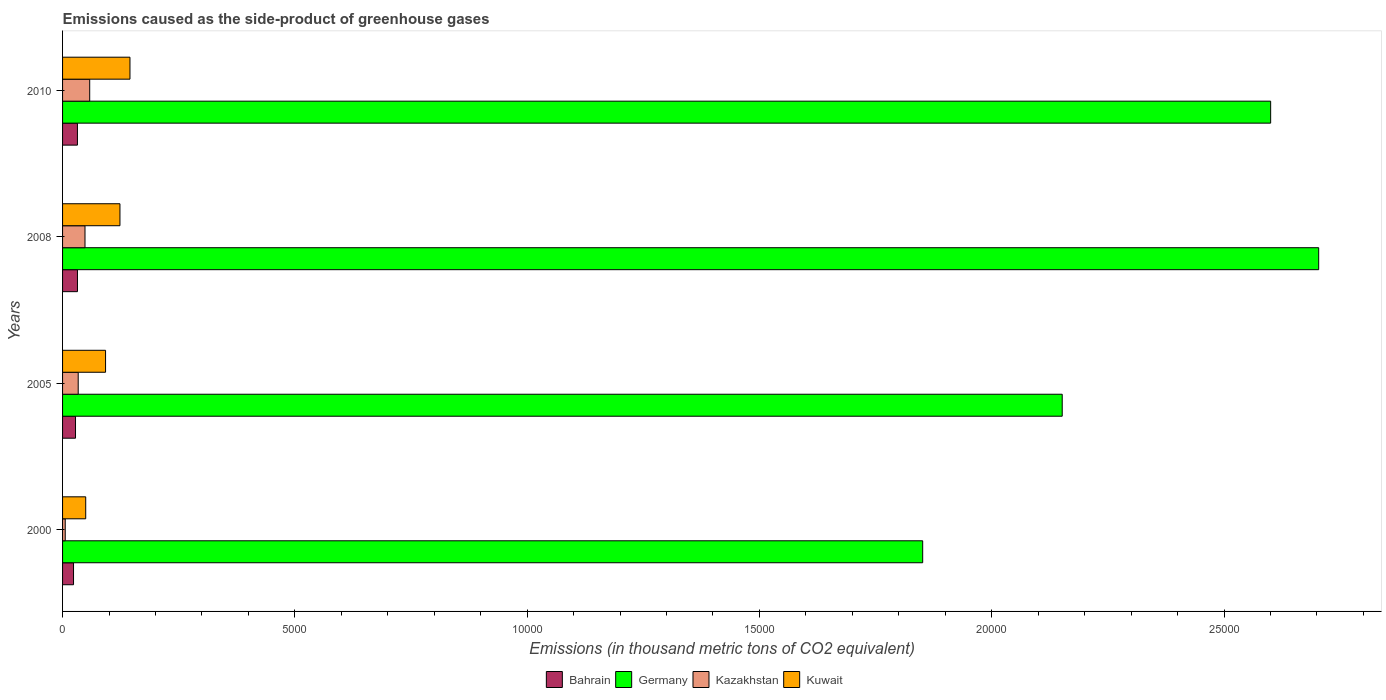How many different coloured bars are there?
Give a very brief answer. 4. Are the number of bars on each tick of the Y-axis equal?
Provide a short and direct response. Yes. How many bars are there on the 4th tick from the bottom?
Provide a short and direct response. 4. What is the label of the 3rd group of bars from the top?
Your response must be concise. 2005. In how many cases, is the number of bars for a given year not equal to the number of legend labels?
Make the answer very short. 0. What is the emissions caused as the side-product of greenhouse gases in Germany in 2008?
Your response must be concise. 2.70e+04. Across all years, what is the maximum emissions caused as the side-product of greenhouse gases in Bahrain?
Offer a terse response. 320.9. Across all years, what is the minimum emissions caused as the side-product of greenhouse gases in Bahrain?
Your response must be concise. 236.1. What is the total emissions caused as the side-product of greenhouse gases in Germany in the graph?
Provide a short and direct response. 9.31e+04. What is the difference between the emissions caused as the side-product of greenhouse gases in Bahrain in 2000 and that in 2005?
Keep it short and to the point. -42.5. What is the difference between the emissions caused as the side-product of greenhouse gases in Germany in 2010 and the emissions caused as the side-product of greenhouse gases in Kazakhstan in 2000?
Offer a terse response. 2.59e+04. What is the average emissions caused as the side-product of greenhouse gases in Kuwait per year?
Offer a terse response. 1027.55. In the year 2008, what is the difference between the emissions caused as the side-product of greenhouse gases in Kuwait and emissions caused as the side-product of greenhouse gases in Germany?
Your response must be concise. -2.58e+04. What is the ratio of the emissions caused as the side-product of greenhouse gases in Kazakhstan in 2005 to that in 2008?
Ensure brevity in your answer.  0.7. What is the difference between the highest and the second highest emissions caused as the side-product of greenhouse gases in Kazakhstan?
Your response must be concise. 101.1. What is the difference between the highest and the lowest emissions caused as the side-product of greenhouse gases in Kazakhstan?
Your answer should be very brief. 526.5. Is the sum of the emissions caused as the side-product of greenhouse gases in Kuwait in 2000 and 2005 greater than the maximum emissions caused as the side-product of greenhouse gases in Bahrain across all years?
Ensure brevity in your answer.  Yes. What does the 3rd bar from the top in 2008 represents?
Keep it short and to the point. Germany. What does the 3rd bar from the bottom in 2000 represents?
Provide a short and direct response. Kazakhstan. How many bars are there?
Give a very brief answer. 16. How many years are there in the graph?
Make the answer very short. 4. Are the values on the major ticks of X-axis written in scientific E-notation?
Offer a terse response. No. Where does the legend appear in the graph?
Your answer should be very brief. Bottom center. How are the legend labels stacked?
Make the answer very short. Horizontal. What is the title of the graph?
Provide a succinct answer. Emissions caused as the side-product of greenhouse gases. What is the label or title of the X-axis?
Offer a very short reply. Emissions (in thousand metric tons of CO2 equivalent). What is the Emissions (in thousand metric tons of CO2 equivalent) of Bahrain in 2000?
Ensure brevity in your answer.  236.1. What is the Emissions (in thousand metric tons of CO2 equivalent) in Germany in 2000?
Ensure brevity in your answer.  1.85e+04. What is the Emissions (in thousand metric tons of CO2 equivalent) in Kazakhstan in 2000?
Keep it short and to the point. 57.5. What is the Emissions (in thousand metric tons of CO2 equivalent) of Kuwait in 2000?
Your response must be concise. 498.2. What is the Emissions (in thousand metric tons of CO2 equivalent) in Bahrain in 2005?
Offer a very short reply. 278.6. What is the Emissions (in thousand metric tons of CO2 equivalent) in Germany in 2005?
Ensure brevity in your answer.  2.15e+04. What is the Emissions (in thousand metric tons of CO2 equivalent) in Kazakhstan in 2005?
Provide a succinct answer. 336.7. What is the Emissions (in thousand metric tons of CO2 equivalent) of Kuwait in 2005?
Provide a succinct answer. 925.6. What is the Emissions (in thousand metric tons of CO2 equivalent) of Bahrain in 2008?
Provide a succinct answer. 320.9. What is the Emissions (in thousand metric tons of CO2 equivalent) in Germany in 2008?
Your answer should be very brief. 2.70e+04. What is the Emissions (in thousand metric tons of CO2 equivalent) of Kazakhstan in 2008?
Keep it short and to the point. 482.9. What is the Emissions (in thousand metric tons of CO2 equivalent) in Kuwait in 2008?
Offer a terse response. 1235.4. What is the Emissions (in thousand metric tons of CO2 equivalent) in Bahrain in 2010?
Keep it short and to the point. 320. What is the Emissions (in thousand metric tons of CO2 equivalent) in Germany in 2010?
Ensure brevity in your answer.  2.60e+04. What is the Emissions (in thousand metric tons of CO2 equivalent) of Kazakhstan in 2010?
Provide a succinct answer. 584. What is the Emissions (in thousand metric tons of CO2 equivalent) in Kuwait in 2010?
Offer a very short reply. 1451. Across all years, what is the maximum Emissions (in thousand metric tons of CO2 equivalent) of Bahrain?
Your response must be concise. 320.9. Across all years, what is the maximum Emissions (in thousand metric tons of CO2 equivalent) of Germany?
Provide a succinct answer. 2.70e+04. Across all years, what is the maximum Emissions (in thousand metric tons of CO2 equivalent) of Kazakhstan?
Offer a terse response. 584. Across all years, what is the maximum Emissions (in thousand metric tons of CO2 equivalent) of Kuwait?
Make the answer very short. 1451. Across all years, what is the minimum Emissions (in thousand metric tons of CO2 equivalent) of Bahrain?
Give a very brief answer. 236.1. Across all years, what is the minimum Emissions (in thousand metric tons of CO2 equivalent) in Germany?
Provide a short and direct response. 1.85e+04. Across all years, what is the minimum Emissions (in thousand metric tons of CO2 equivalent) of Kazakhstan?
Your answer should be very brief. 57.5. Across all years, what is the minimum Emissions (in thousand metric tons of CO2 equivalent) in Kuwait?
Make the answer very short. 498.2. What is the total Emissions (in thousand metric tons of CO2 equivalent) of Bahrain in the graph?
Make the answer very short. 1155.6. What is the total Emissions (in thousand metric tons of CO2 equivalent) of Germany in the graph?
Give a very brief answer. 9.31e+04. What is the total Emissions (in thousand metric tons of CO2 equivalent) of Kazakhstan in the graph?
Give a very brief answer. 1461.1. What is the total Emissions (in thousand metric tons of CO2 equivalent) in Kuwait in the graph?
Your answer should be compact. 4110.2. What is the difference between the Emissions (in thousand metric tons of CO2 equivalent) of Bahrain in 2000 and that in 2005?
Your answer should be compact. -42.5. What is the difference between the Emissions (in thousand metric tons of CO2 equivalent) of Germany in 2000 and that in 2005?
Ensure brevity in your answer.  -3003.6. What is the difference between the Emissions (in thousand metric tons of CO2 equivalent) in Kazakhstan in 2000 and that in 2005?
Your answer should be very brief. -279.2. What is the difference between the Emissions (in thousand metric tons of CO2 equivalent) of Kuwait in 2000 and that in 2005?
Make the answer very short. -427.4. What is the difference between the Emissions (in thousand metric tons of CO2 equivalent) of Bahrain in 2000 and that in 2008?
Your answer should be compact. -84.8. What is the difference between the Emissions (in thousand metric tons of CO2 equivalent) in Germany in 2000 and that in 2008?
Offer a terse response. -8523.9. What is the difference between the Emissions (in thousand metric tons of CO2 equivalent) in Kazakhstan in 2000 and that in 2008?
Make the answer very short. -425.4. What is the difference between the Emissions (in thousand metric tons of CO2 equivalent) in Kuwait in 2000 and that in 2008?
Your answer should be compact. -737.2. What is the difference between the Emissions (in thousand metric tons of CO2 equivalent) of Bahrain in 2000 and that in 2010?
Your answer should be compact. -83.9. What is the difference between the Emissions (in thousand metric tons of CO2 equivalent) of Germany in 2000 and that in 2010?
Offer a very short reply. -7490.1. What is the difference between the Emissions (in thousand metric tons of CO2 equivalent) of Kazakhstan in 2000 and that in 2010?
Your response must be concise. -526.5. What is the difference between the Emissions (in thousand metric tons of CO2 equivalent) of Kuwait in 2000 and that in 2010?
Your response must be concise. -952.8. What is the difference between the Emissions (in thousand metric tons of CO2 equivalent) of Bahrain in 2005 and that in 2008?
Keep it short and to the point. -42.3. What is the difference between the Emissions (in thousand metric tons of CO2 equivalent) in Germany in 2005 and that in 2008?
Your response must be concise. -5520.3. What is the difference between the Emissions (in thousand metric tons of CO2 equivalent) of Kazakhstan in 2005 and that in 2008?
Your answer should be very brief. -146.2. What is the difference between the Emissions (in thousand metric tons of CO2 equivalent) of Kuwait in 2005 and that in 2008?
Give a very brief answer. -309.8. What is the difference between the Emissions (in thousand metric tons of CO2 equivalent) of Bahrain in 2005 and that in 2010?
Give a very brief answer. -41.4. What is the difference between the Emissions (in thousand metric tons of CO2 equivalent) of Germany in 2005 and that in 2010?
Your response must be concise. -4486.5. What is the difference between the Emissions (in thousand metric tons of CO2 equivalent) in Kazakhstan in 2005 and that in 2010?
Your response must be concise. -247.3. What is the difference between the Emissions (in thousand metric tons of CO2 equivalent) of Kuwait in 2005 and that in 2010?
Provide a short and direct response. -525.4. What is the difference between the Emissions (in thousand metric tons of CO2 equivalent) of Germany in 2008 and that in 2010?
Ensure brevity in your answer.  1033.8. What is the difference between the Emissions (in thousand metric tons of CO2 equivalent) in Kazakhstan in 2008 and that in 2010?
Ensure brevity in your answer.  -101.1. What is the difference between the Emissions (in thousand metric tons of CO2 equivalent) in Kuwait in 2008 and that in 2010?
Your response must be concise. -215.6. What is the difference between the Emissions (in thousand metric tons of CO2 equivalent) of Bahrain in 2000 and the Emissions (in thousand metric tons of CO2 equivalent) of Germany in 2005?
Offer a very short reply. -2.13e+04. What is the difference between the Emissions (in thousand metric tons of CO2 equivalent) of Bahrain in 2000 and the Emissions (in thousand metric tons of CO2 equivalent) of Kazakhstan in 2005?
Make the answer very short. -100.6. What is the difference between the Emissions (in thousand metric tons of CO2 equivalent) in Bahrain in 2000 and the Emissions (in thousand metric tons of CO2 equivalent) in Kuwait in 2005?
Your response must be concise. -689.5. What is the difference between the Emissions (in thousand metric tons of CO2 equivalent) in Germany in 2000 and the Emissions (in thousand metric tons of CO2 equivalent) in Kazakhstan in 2005?
Offer a very short reply. 1.82e+04. What is the difference between the Emissions (in thousand metric tons of CO2 equivalent) in Germany in 2000 and the Emissions (in thousand metric tons of CO2 equivalent) in Kuwait in 2005?
Your response must be concise. 1.76e+04. What is the difference between the Emissions (in thousand metric tons of CO2 equivalent) in Kazakhstan in 2000 and the Emissions (in thousand metric tons of CO2 equivalent) in Kuwait in 2005?
Your response must be concise. -868.1. What is the difference between the Emissions (in thousand metric tons of CO2 equivalent) in Bahrain in 2000 and the Emissions (in thousand metric tons of CO2 equivalent) in Germany in 2008?
Provide a short and direct response. -2.68e+04. What is the difference between the Emissions (in thousand metric tons of CO2 equivalent) in Bahrain in 2000 and the Emissions (in thousand metric tons of CO2 equivalent) in Kazakhstan in 2008?
Your response must be concise. -246.8. What is the difference between the Emissions (in thousand metric tons of CO2 equivalent) of Bahrain in 2000 and the Emissions (in thousand metric tons of CO2 equivalent) of Kuwait in 2008?
Give a very brief answer. -999.3. What is the difference between the Emissions (in thousand metric tons of CO2 equivalent) of Germany in 2000 and the Emissions (in thousand metric tons of CO2 equivalent) of Kazakhstan in 2008?
Ensure brevity in your answer.  1.80e+04. What is the difference between the Emissions (in thousand metric tons of CO2 equivalent) in Germany in 2000 and the Emissions (in thousand metric tons of CO2 equivalent) in Kuwait in 2008?
Offer a very short reply. 1.73e+04. What is the difference between the Emissions (in thousand metric tons of CO2 equivalent) of Kazakhstan in 2000 and the Emissions (in thousand metric tons of CO2 equivalent) of Kuwait in 2008?
Give a very brief answer. -1177.9. What is the difference between the Emissions (in thousand metric tons of CO2 equivalent) in Bahrain in 2000 and the Emissions (in thousand metric tons of CO2 equivalent) in Germany in 2010?
Your answer should be very brief. -2.58e+04. What is the difference between the Emissions (in thousand metric tons of CO2 equivalent) of Bahrain in 2000 and the Emissions (in thousand metric tons of CO2 equivalent) of Kazakhstan in 2010?
Keep it short and to the point. -347.9. What is the difference between the Emissions (in thousand metric tons of CO2 equivalent) of Bahrain in 2000 and the Emissions (in thousand metric tons of CO2 equivalent) of Kuwait in 2010?
Provide a succinct answer. -1214.9. What is the difference between the Emissions (in thousand metric tons of CO2 equivalent) of Germany in 2000 and the Emissions (in thousand metric tons of CO2 equivalent) of Kazakhstan in 2010?
Keep it short and to the point. 1.79e+04. What is the difference between the Emissions (in thousand metric tons of CO2 equivalent) in Germany in 2000 and the Emissions (in thousand metric tons of CO2 equivalent) in Kuwait in 2010?
Keep it short and to the point. 1.71e+04. What is the difference between the Emissions (in thousand metric tons of CO2 equivalent) of Kazakhstan in 2000 and the Emissions (in thousand metric tons of CO2 equivalent) of Kuwait in 2010?
Give a very brief answer. -1393.5. What is the difference between the Emissions (in thousand metric tons of CO2 equivalent) in Bahrain in 2005 and the Emissions (in thousand metric tons of CO2 equivalent) in Germany in 2008?
Ensure brevity in your answer.  -2.68e+04. What is the difference between the Emissions (in thousand metric tons of CO2 equivalent) of Bahrain in 2005 and the Emissions (in thousand metric tons of CO2 equivalent) of Kazakhstan in 2008?
Offer a very short reply. -204.3. What is the difference between the Emissions (in thousand metric tons of CO2 equivalent) of Bahrain in 2005 and the Emissions (in thousand metric tons of CO2 equivalent) of Kuwait in 2008?
Offer a terse response. -956.8. What is the difference between the Emissions (in thousand metric tons of CO2 equivalent) in Germany in 2005 and the Emissions (in thousand metric tons of CO2 equivalent) in Kazakhstan in 2008?
Keep it short and to the point. 2.10e+04. What is the difference between the Emissions (in thousand metric tons of CO2 equivalent) in Germany in 2005 and the Emissions (in thousand metric tons of CO2 equivalent) in Kuwait in 2008?
Keep it short and to the point. 2.03e+04. What is the difference between the Emissions (in thousand metric tons of CO2 equivalent) of Kazakhstan in 2005 and the Emissions (in thousand metric tons of CO2 equivalent) of Kuwait in 2008?
Ensure brevity in your answer.  -898.7. What is the difference between the Emissions (in thousand metric tons of CO2 equivalent) of Bahrain in 2005 and the Emissions (in thousand metric tons of CO2 equivalent) of Germany in 2010?
Provide a short and direct response. -2.57e+04. What is the difference between the Emissions (in thousand metric tons of CO2 equivalent) in Bahrain in 2005 and the Emissions (in thousand metric tons of CO2 equivalent) in Kazakhstan in 2010?
Provide a short and direct response. -305.4. What is the difference between the Emissions (in thousand metric tons of CO2 equivalent) of Bahrain in 2005 and the Emissions (in thousand metric tons of CO2 equivalent) of Kuwait in 2010?
Ensure brevity in your answer.  -1172.4. What is the difference between the Emissions (in thousand metric tons of CO2 equivalent) of Germany in 2005 and the Emissions (in thousand metric tons of CO2 equivalent) of Kazakhstan in 2010?
Your answer should be compact. 2.09e+04. What is the difference between the Emissions (in thousand metric tons of CO2 equivalent) in Germany in 2005 and the Emissions (in thousand metric tons of CO2 equivalent) in Kuwait in 2010?
Keep it short and to the point. 2.01e+04. What is the difference between the Emissions (in thousand metric tons of CO2 equivalent) of Kazakhstan in 2005 and the Emissions (in thousand metric tons of CO2 equivalent) of Kuwait in 2010?
Your response must be concise. -1114.3. What is the difference between the Emissions (in thousand metric tons of CO2 equivalent) in Bahrain in 2008 and the Emissions (in thousand metric tons of CO2 equivalent) in Germany in 2010?
Provide a short and direct response. -2.57e+04. What is the difference between the Emissions (in thousand metric tons of CO2 equivalent) of Bahrain in 2008 and the Emissions (in thousand metric tons of CO2 equivalent) of Kazakhstan in 2010?
Your response must be concise. -263.1. What is the difference between the Emissions (in thousand metric tons of CO2 equivalent) in Bahrain in 2008 and the Emissions (in thousand metric tons of CO2 equivalent) in Kuwait in 2010?
Offer a very short reply. -1130.1. What is the difference between the Emissions (in thousand metric tons of CO2 equivalent) in Germany in 2008 and the Emissions (in thousand metric tons of CO2 equivalent) in Kazakhstan in 2010?
Provide a succinct answer. 2.65e+04. What is the difference between the Emissions (in thousand metric tons of CO2 equivalent) in Germany in 2008 and the Emissions (in thousand metric tons of CO2 equivalent) in Kuwait in 2010?
Make the answer very short. 2.56e+04. What is the difference between the Emissions (in thousand metric tons of CO2 equivalent) of Kazakhstan in 2008 and the Emissions (in thousand metric tons of CO2 equivalent) of Kuwait in 2010?
Offer a very short reply. -968.1. What is the average Emissions (in thousand metric tons of CO2 equivalent) of Bahrain per year?
Ensure brevity in your answer.  288.9. What is the average Emissions (in thousand metric tons of CO2 equivalent) in Germany per year?
Your answer should be compact. 2.33e+04. What is the average Emissions (in thousand metric tons of CO2 equivalent) of Kazakhstan per year?
Ensure brevity in your answer.  365.27. What is the average Emissions (in thousand metric tons of CO2 equivalent) of Kuwait per year?
Your response must be concise. 1027.55. In the year 2000, what is the difference between the Emissions (in thousand metric tons of CO2 equivalent) of Bahrain and Emissions (in thousand metric tons of CO2 equivalent) of Germany?
Your answer should be compact. -1.83e+04. In the year 2000, what is the difference between the Emissions (in thousand metric tons of CO2 equivalent) of Bahrain and Emissions (in thousand metric tons of CO2 equivalent) of Kazakhstan?
Offer a terse response. 178.6. In the year 2000, what is the difference between the Emissions (in thousand metric tons of CO2 equivalent) in Bahrain and Emissions (in thousand metric tons of CO2 equivalent) in Kuwait?
Provide a succinct answer. -262.1. In the year 2000, what is the difference between the Emissions (in thousand metric tons of CO2 equivalent) of Germany and Emissions (in thousand metric tons of CO2 equivalent) of Kazakhstan?
Make the answer very short. 1.85e+04. In the year 2000, what is the difference between the Emissions (in thousand metric tons of CO2 equivalent) of Germany and Emissions (in thousand metric tons of CO2 equivalent) of Kuwait?
Provide a short and direct response. 1.80e+04. In the year 2000, what is the difference between the Emissions (in thousand metric tons of CO2 equivalent) of Kazakhstan and Emissions (in thousand metric tons of CO2 equivalent) of Kuwait?
Provide a short and direct response. -440.7. In the year 2005, what is the difference between the Emissions (in thousand metric tons of CO2 equivalent) of Bahrain and Emissions (in thousand metric tons of CO2 equivalent) of Germany?
Keep it short and to the point. -2.12e+04. In the year 2005, what is the difference between the Emissions (in thousand metric tons of CO2 equivalent) of Bahrain and Emissions (in thousand metric tons of CO2 equivalent) of Kazakhstan?
Ensure brevity in your answer.  -58.1. In the year 2005, what is the difference between the Emissions (in thousand metric tons of CO2 equivalent) in Bahrain and Emissions (in thousand metric tons of CO2 equivalent) in Kuwait?
Your answer should be very brief. -647. In the year 2005, what is the difference between the Emissions (in thousand metric tons of CO2 equivalent) of Germany and Emissions (in thousand metric tons of CO2 equivalent) of Kazakhstan?
Make the answer very short. 2.12e+04. In the year 2005, what is the difference between the Emissions (in thousand metric tons of CO2 equivalent) of Germany and Emissions (in thousand metric tons of CO2 equivalent) of Kuwait?
Offer a terse response. 2.06e+04. In the year 2005, what is the difference between the Emissions (in thousand metric tons of CO2 equivalent) in Kazakhstan and Emissions (in thousand metric tons of CO2 equivalent) in Kuwait?
Give a very brief answer. -588.9. In the year 2008, what is the difference between the Emissions (in thousand metric tons of CO2 equivalent) of Bahrain and Emissions (in thousand metric tons of CO2 equivalent) of Germany?
Offer a very short reply. -2.67e+04. In the year 2008, what is the difference between the Emissions (in thousand metric tons of CO2 equivalent) of Bahrain and Emissions (in thousand metric tons of CO2 equivalent) of Kazakhstan?
Offer a terse response. -162. In the year 2008, what is the difference between the Emissions (in thousand metric tons of CO2 equivalent) in Bahrain and Emissions (in thousand metric tons of CO2 equivalent) in Kuwait?
Ensure brevity in your answer.  -914.5. In the year 2008, what is the difference between the Emissions (in thousand metric tons of CO2 equivalent) of Germany and Emissions (in thousand metric tons of CO2 equivalent) of Kazakhstan?
Make the answer very short. 2.66e+04. In the year 2008, what is the difference between the Emissions (in thousand metric tons of CO2 equivalent) in Germany and Emissions (in thousand metric tons of CO2 equivalent) in Kuwait?
Give a very brief answer. 2.58e+04. In the year 2008, what is the difference between the Emissions (in thousand metric tons of CO2 equivalent) of Kazakhstan and Emissions (in thousand metric tons of CO2 equivalent) of Kuwait?
Give a very brief answer. -752.5. In the year 2010, what is the difference between the Emissions (in thousand metric tons of CO2 equivalent) of Bahrain and Emissions (in thousand metric tons of CO2 equivalent) of Germany?
Provide a short and direct response. -2.57e+04. In the year 2010, what is the difference between the Emissions (in thousand metric tons of CO2 equivalent) of Bahrain and Emissions (in thousand metric tons of CO2 equivalent) of Kazakhstan?
Provide a short and direct response. -264. In the year 2010, what is the difference between the Emissions (in thousand metric tons of CO2 equivalent) in Bahrain and Emissions (in thousand metric tons of CO2 equivalent) in Kuwait?
Offer a terse response. -1131. In the year 2010, what is the difference between the Emissions (in thousand metric tons of CO2 equivalent) of Germany and Emissions (in thousand metric tons of CO2 equivalent) of Kazakhstan?
Your answer should be compact. 2.54e+04. In the year 2010, what is the difference between the Emissions (in thousand metric tons of CO2 equivalent) of Germany and Emissions (in thousand metric tons of CO2 equivalent) of Kuwait?
Keep it short and to the point. 2.46e+04. In the year 2010, what is the difference between the Emissions (in thousand metric tons of CO2 equivalent) of Kazakhstan and Emissions (in thousand metric tons of CO2 equivalent) of Kuwait?
Your answer should be very brief. -867. What is the ratio of the Emissions (in thousand metric tons of CO2 equivalent) in Bahrain in 2000 to that in 2005?
Provide a succinct answer. 0.85. What is the ratio of the Emissions (in thousand metric tons of CO2 equivalent) of Germany in 2000 to that in 2005?
Ensure brevity in your answer.  0.86. What is the ratio of the Emissions (in thousand metric tons of CO2 equivalent) of Kazakhstan in 2000 to that in 2005?
Offer a very short reply. 0.17. What is the ratio of the Emissions (in thousand metric tons of CO2 equivalent) in Kuwait in 2000 to that in 2005?
Offer a terse response. 0.54. What is the ratio of the Emissions (in thousand metric tons of CO2 equivalent) in Bahrain in 2000 to that in 2008?
Ensure brevity in your answer.  0.74. What is the ratio of the Emissions (in thousand metric tons of CO2 equivalent) in Germany in 2000 to that in 2008?
Offer a terse response. 0.68. What is the ratio of the Emissions (in thousand metric tons of CO2 equivalent) of Kazakhstan in 2000 to that in 2008?
Make the answer very short. 0.12. What is the ratio of the Emissions (in thousand metric tons of CO2 equivalent) of Kuwait in 2000 to that in 2008?
Your response must be concise. 0.4. What is the ratio of the Emissions (in thousand metric tons of CO2 equivalent) of Bahrain in 2000 to that in 2010?
Provide a short and direct response. 0.74. What is the ratio of the Emissions (in thousand metric tons of CO2 equivalent) in Germany in 2000 to that in 2010?
Give a very brief answer. 0.71. What is the ratio of the Emissions (in thousand metric tons of CO2 equivalent) in Kazakhstan in 2000 to that in 2010?
Your answer should be compact. 0.1. What is the ratio of the Emissions (in thousand metric tons of CO2 equivalent) in Kuwait in 2000 to that in 2010?
Offer a terse response. 0.34. What is the ratio of the Emissions (in thousand metric tons of CO2 equivalent) in Bahrain in 2005 to that in 2008?
Your answer should be very brief. 0.87. What is the ratio of the Emissions (in thousand metric tons of CO2 equivalent) in Germany in 2005 to that in 2008?
Ensure brevity in your answer.  0.8. What is the ratio of the Emissions (in thousand metric tons of CO2 equivalent) of Kazakhstan in 2005 to that in 2008?
Keep it short and to the point. 0.7. What is the ratio of the Emissions (in thousand metric tons of CO2 equivalent) of Kuwait in 2005 to that in 2008?
Provide a short and direct response. 0.75. What is the ratio of the Emissions (in thousand metric tons of CO2 equivalent) in Bahrain in 2005 to that in 2010?
Your answer should be very brief. 0.87. What is the ratio of the Emissions (in thousand metric tons of CO2 equivalent) in Germany in 2005 to that in 2010?
Give a very brief answer. 0.83. What is the ratio of the Emissions (in thousand metric tons of CO2 equivalent) in Kazakhstan in 2005 to that in 2010?
Your response must be concise. 0.58. What is the ratio of the Emissions (in thousand metric tons of CO2 equivalent) of Kuwait in 2005 to that in 2010?
Your response must be concise. 0.64. What is the ratio of the Emissions (in thousand metric tons of CO2 equivalent) in Bahrain in 2008 to that in 2010?
Ensure brevity in your answer.  1. What is the ratio of the Emissions (in thousand metric tons of CO2 equivalent) in Germany in 2008 to that in 2010?
Your answer should be compact. 1.04. What is the ratio of the Emissions (in thousand metric tons of CO2 equivalent) in Kazakhstan in 2008 to that in 2010?
Your answer should be compact. 0.83. What is the ratio of the Emissions (in thousand metric tons of CO2 equivalent) in Kuwait in 2008 to that in 2010?
Give a very brief answer. 0.85. What is the difference between the highest and the second highest Emissions (in thousand metric tons of CO2 equivalent) of Bahrain?
Provide a succinct answer. 0.9. What is the difference between the highest and the second highest Emissions (in thousand metric tons of CO2 equivalent) in Germany?
Keep it short and to the point. 1033.8. What is the difference between the highest and the second highest Emissions (in thousand metric tons of CO2 equivalent) of Kazakhstan?
Your answer should be very brief. 101.1. What is the difference between the highest and the second highest Emissions (in thousand metric tons of CO2 equivalent) in Kuwait?
Provide a short and direct response. 215.6. What is the difference between the highest and the lowest Emissions (in thousand metric tons of CO2 equivalent) in Bahrain?
Make the answer very short. 84.8. What is the difference between the highest and the lowest Emissions (in thousand metric tons of CO2 equivalent) of Germany?
Your answer should be compact. 8523.9. What is the difference between the highest and the lowest Emissions (in thousand metric tons of CO2 equivalent) of Kazakhstan?
Keep it short and to the point. 526.5. What is the difference between the highest and the lowest Emissions (in thousand metric tons of CO2 equivalent) in Kuwait?
Make the answer very short. 952.8. 